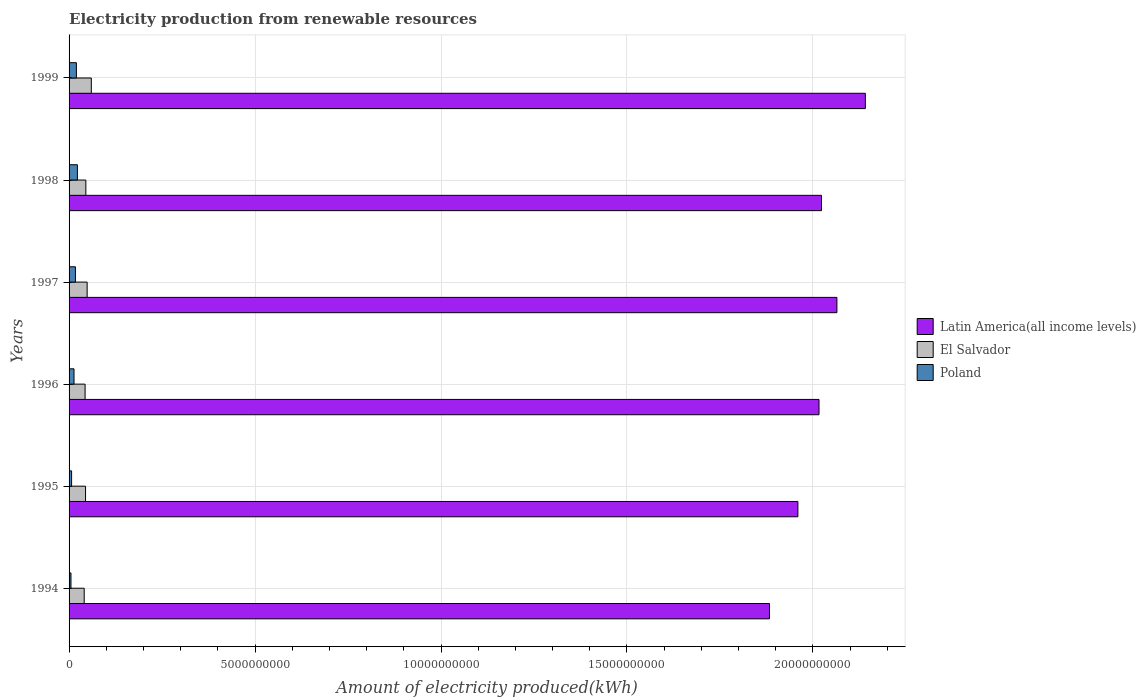Are the number of bars per tick equal to the number of legend labels?
Give a very brief answer. Yes. How many bars are there on the 1st tick from the top?
Keep it short and to the point. 3. What is the label of the 2nd group of bars from the top?
Your answer should be compact. 1998. In how many cases, is the number of bars for a given year not equal to the number of legend labels?
Provide a short and direct response. 0. What is the amount of electricity produced in Latin America(all income levels) in 1996?
Keep it short and to the point. 2.02e+1. Across all years, what is the maximum amount of electricity produced in El Salvador?
Your answer should be compact. 5.98e+08. Across all years, what is the minimum amount of electricity produced in Poland?
Give a very brief answer. 5.10e+07. In which year was the amount of electricity produced in Latin America(all income levels) maximum?
Provide a short and direct response. 1999. What is the total amount of electricity produced in Latin America(all income levels) in the graph?
Your answer should be compact. 1.21e+11. What is the difference between the amount of electricity produced in Latin America(all income levels) in 1994 and that in 1999?
Keep it short and to the point. -2.58e+09. What is the difference between the amount of electricity produced in El Salvador in 1994 and the amount of electricity produced in Latin America(all income levels) in 1996?
Your answer should be compact. -1.98e+1. What is the average amount of electricity produced in Poland per year?
Offer a terse response. 1.41e+08. In the year 1999, what is the difference between the amount of electricity produced in El Salvador and amount of electricity produced in Latin America(all income levels)?
Ensure brevity in your answer.  -2.08e+1. What is the ratio of the amount of electricity produced in Latin America(all income levels) in 1994 to that in 1996?
Give a very brief answer. 0.93. Is the amount of electricity produced in Latin America(all income levels) in 1997 less than that in 1998?
Ensure brevity in your answer.  No. Is the difference between the amount of electricity produced in El Salvador in 1995 and 1997 greater than the difference between the amount of electricity produced in Latin America(all income levels) in 1995 and 1997?
Offer a very short reply. Yes. What is the difference between the highest and the second highest amount of electricity produced in Latin America(all income levels)?
Your response must be concise. 7.65e+08. What is the difference between the highest and the lowest amount of electricity produced in Latin America(all income levels)?
Keep it short and to the point. 2.58e+09. In how many years, is the amount of electricity produced in Latin America(all income levels) greater than the average amount of electricity produced in Latin America(all income levels) taken over all years?
Your answer should be compact. 4. Is the sum of the amount of electricity produced in Latin America(all income levels) in 1996 and 1997 greater than the maximum amount of electricity produced in El Salvador across all years?
Provide a short and direct response. Yes. What does the 2nd bar from the top in 1994 represents?
Provide a short and direct response. El Salvador. What does the 3rd bar from the bottom in 1998 represents?
Make the answer very short. Poland. Is it the case that in every year, the sum of the amount of electricity produced in Latin America(all income levels) and amount of electricity produced in Poland is greater than the amount of electricity produced in El Salvador?
Provide a short and direct response. Yes. What is the difference between two consecutive major ticks on the X-axis?
Give a very brief answer. 5.00e+09. Are the values on the major ticks of X-axis written in scientific E-notation?
Your response must be concise. No. Does the graph contain any zero values?
Provide a succinct answer. No. Does the graph contain grids?
Provide a short and direct response. Yes. How many legend labels are there?
Your answer should be very brief. 3. What is the title of the graph?
Provide a succinct answer. Electricity production from renewable resources. Does "Lao PDR" appear as one of the legend labels in the graph?
Give a very brief answer. No. What is the label or title of the X-axis?
Make the answer very short. Amount of electricity produced(kWh). What is the Amount of electricity produced(kWh) of Latin America(all income levels) in 1994?
Ensure brevity in your answer.  1.88e+1. What is the Amount of electricity produced(kWh) of El Salvador in 1994?
Provide a succinct answer. 4.07e+08. What is the Amount of electricity produced(kWh) of Poland in 1994?
Your answer should be compact. 5.10e+07. What is the Amount of electricity produced(kWh) in Latin America(all income levels) in 1995?
Ensure brevity in your answer.  1.96e+1. What is the Amount of electricity produced(kWh) of El Salvador in 1995?
Give a very brief answer. 4.43e+08. What is the Amount of electricity produced(kWh) in Poland in 1995?
Your response must be concise. 6.80e+07. What is the Amount of electricity produced(kWh) in Latin America(all income levels) in 1996?
Your response must be concise. 2.02e+1. What is the Amount of electricity produced(kWh) of El Salvador in 1996?
Ensure brevity in your answer.  4.31e+08. What is the Amount of electricity produced(kWh) of Poland in 1996?
Give a very brief answer. 1.33e+08. What is the Amount of electricity produced(kWh) in Latin America(all income levels) in 1997?
Your answer should be very brief. 2.06e+1. What is the Amount of electricity produced(kWh) in El Salvador in 1997?
Ensure brevity in your answer.  4.86e+08. What is the Amount of electricity produced(kWh) of Poland in 1997?
Your answer should be compact. 1.71e+08. What is the Amount of electricity produced(kWh) of Latin America(all income levels) in 1998?
Keep it short and to the point. 2.02e+1. What is the Amount of electricity produced(kWh) in El Salvador in 1998?
Ensure brevity in your answer.  4.51e+08. What is the Amount of electricity produced(kWh) in Poland in 1998?
Provide a short and direct response. 2.24e+08. What is the Amount of electricity produced(kWh) of Latin America(all income levels) in 1999?
Offer a terse response. 2.14e+1. What is the Amount of electricity produced(kWh) in El Salvador in 1999?
Offer a terse response. 5.98e+08. What is the Amount of electricity produced(kWh) of Poland in 1999?
Your answer should be very brief. 1.97e+08. Across all years, what is the maximum Amount of electricity produced(kWh) in Latin America(all income levels)?
Give a very brief answer. 2.14e+1. Across all years, what is the maximum Amount of electricity produced(kWh) of El Salvador?
Offer a terse response. 5.98e+08. Across all years, what is the maximum Amount of electricity produced(kWh) in Poland?
Keep it short and to the point. 2.24e+08. Across all years, what is the minimum Amount of electricity produced(kWh) in Latin America(all income levels)?
Make the answer very short. 1.88e+1. Across all years, what is the minimum Amount of electricity produced(kWh) in El Salvador?
Ensure brevity in your answer.  4.07e+08. Across all years, what is the minimum Amount of electricity produced(kWh) in Poland?
Provide a succinct answer. 5.10e+07. What is the total Amount of electricity produced(kWh) of Latin America(all income levels) in the graph?
Offer a terse response. 1.21e+11. What is the total Amount of electricity produced(kWh) in El Salvador in the graph?
Your answer should be compact. 2.82e+09. What is the total Amount of electricity produced(kWh) of Poland in the graph?
Make the answer very short. 8.44e+08. What is the difference between the Amount of electricity produced(kWh) of Latin America(all income levels) in 1994 and that in 1995?
Your answer should be very brief. -7.64e+08. What is the difference between the Amount of electricity produced(kWh) of El Salvador in 1994 and that in 1995?
Keep it short and to the point. -3.60e+07. What is the difference between the Amount of electricity produced(kWh) in Poland in 1994 and that in 1995?
Offer a terse response. -1.70e+07. What is the difference between the Amount of electricity produced(kWh) of Latin America(all income levels) in 1994 and that in 1996?
Provide a short and direct response. -1.33e+09. What is the difference between the Amount of electricity produced(kWh) in El Salvador in 1994 and that in 1996?
Keep it short and to the point. -2.40e+07. What is the difference between the Amount of electricity produced(kWh) in Poland in 1994 and that in 1996?
Give a very brief answer. -8.20e+07. What is the difference between the Amount of electricity produced(kWh) of Latin America(all income levels) in 1994 and that in 1997?
Give a very brief answer. -1.81e+09. What is the difference between the Amount of electricity produced(kWh) of El Salvador in 1994 and that in 1997?
Provide a short and direct response. -7.90e+07. What is the difference between the Amount of electricity produced(kWh) in Poland in 1994 and that in 1997?
Provide a short and direct response. -1.20e+08. What is the difference between the Amount of electricity produced(kWh) of Latin America(all income levels) in 1994 and that in 1998?
Make the answer very short. -1.40e+09. What is the difference between the Amount of electricity produced(kWh) of El Salvador in 1994 and that in 1998?
Provide a short and direct response. -4.40e+07. What is the difference between the Amount of electricity produced(kWh) in Poland in 1994 and that in 1998?
Keep it short and to the point. -1.73e+08. What is the difference between the Amount of electricity produced(kWh) in Latin America(all income levels) in 1994 and that in 1999?
Your answer should be compact. -2.58e+09. What is the difference between the Amount of electricity produced(kWh) of El Salvador in 1994 and that in 1999?
Ensure brevity in your answer.  -1.91e+08. What is the difference between the Amount of electricity produced(kWh) of Poland in 1994 and that in 1999?
Your response must be concise. -1.46e+08. What is the difference between the Amount of electricity produced(kWh) of Latin America(all income levels) in 1995 and that in 1996?
Keep it short and to the point. -5.68e+08. What is the difference between the Amount of electricity produced(kWh) of Poland in 1995 and that in 1996?
Make the answer very short. -6.50e+07. What is the difference between the Amount of electricity produced(kWh) of Latin America(all income levels) in 1995 and that in 1997?
Provide a succinct answer. -1.05e+09. What is the difference between the Amount of electricity produced(kWh) of El Salvador in 1995 and that in 1997?
Offer a very short reply. -4.30e+07. What is the difference between the Amount of electricity produced(kWh) in Poland in 1995 and that in 1997?
Provide a short and direct response. -1.03e+08. What is the difference between the Amount of electricity produced(kWh) in Latin America(all income levels) in 1995 and that in 1998?
Ensure brevity in your answer.  -6.34e+08. What is the difference between the Amount of electricity produced(kWh) in El Salvador in 1995 and that in 1998?
Keep it short and to the point. -8.00e+06. What is the difference between the Amount of electricity produced(kWh) of Poland in 1995 and that in 1998?
Make the answer very short. -1.56e+08. What is the difference between the Amount of electricity produced(kWh) in Latin America(all income levels) in 1995 and that in 1999?
Provide a succinct answer. -1.81e+09. What is the difference between the Amount of electricity produced(kWh) in El Salvador in 1995 and that in 1999?
Provide a short and direct response. -1.55e+08. What is the difference between the Amount of electricity produced(kWh) in Poland in 1995 and that in 1999?
Your response must be concise. -1.29e+08. What is the difference between the Amount of electricity produced(kWh) in Latin America(all income levels) in 1996 and that in 1997?
Give a very brief answer. -4.81e+08. What is the difference between the Amount of electricity produced(kWh) of El Salvador in 1996 and that in 1997?
Your response must be concise. -5.50e+07. What is the difference between the Amount of electricity produced(kWh) of Poland in 1996 and that in 1997?
Keep it short and to the point. -3.80e+07. What is the difference between the Amount of electricity produced(kWh) in Latin America(all income levels) in 1996 and that in 1998?
Provide a succinct answer. -6.60e+07. What is the difference between the Amount of electricity produced(kWh) in El Salvador in 1996 and that in 1998?
Make the answer very short. -2.00e+07. What is the difference between the Amount of electricity produced(kWh) in Poland in 1996 and that in 1998?
Provide a succinct answer. -9.10e+07. What is the difference between the Amount of electricity produced(kWh) of Latin America(all income levels) in 1996 and that in 1999?
Your answer should be compact. -1.25e+09. What is the difference between the Amount of electricity produced(kWh) in El Salvador in 1996 and that in 1999?
Keep it short and to the point. -1.67e+08. What is the difference between the Amount of electricity produced(kWh) in Poland in 1996 and that in 1999?
Your response must be concise. -6.40e+07. What is the difference between the Amount of electricity produced(kWh) of Latin America(all income levels) in 1997 and that in 1998?
Keep it short and to the point. 4.15e+08. What is the difference between the Amount of electricity produced(kWh) of El Salvador in 1997 and that in 1998?
Your response must be concise. 3.50e+07. What is the difference between the Amount of electricity produced(kWh) of Poland in 1997 and that in 1998?
Offer a terse response. -5.30e+07. What is the difference between the Amount of electricity produced(kWh) of Latin America(all income levels) in 1997 and that in 1999?
Your answer should be compact. -7.65e+08. What is the difference between the Amount of electricity produced(kWh) in El Salvador in 1997 and that in 1999?
Keep it short and to the point. -1.12e+08. What is the difference between the Amount of electricity produced(kWh) in Poland in 1997 and that in 1999?
Provide a succinct answer. -2.60e+07. What is the difference between the Amount of electricity produced(kWh) in Latin America(all income levels) in 1998 and that in 1999?
Your response must be concise. -1.18e+09. What is the difference between the Amount of electricity produced(kWh) of El Salvador in 1998 and that in 1999?
Your response must be concise. -1.47e+08. What is the difference between the Amount of electricity produced(kWh) of Poland in 1998 and that in 1999?
Ensure brevity in your answer.  2.70e+07. What is the difference between the Amount of electricity produced(kWh) of Latin America(all income levels) in 1994 and the Amount of electricity produced(kWh) of El Salvador in 1995?
Your answer should be compact. 1.84e+1. What is the difference between the Amount of electricity produced(kWh) in Latin America(all income levels) in 1994 and the Amount of electricity produced(kWh) in Poland in 1995?
Your response must be concise. 1.88e+1. What is the difference between the Amount of electricity produced(kWh) of El Salvador in 1994 and the Amount of electricity produced(kWh) of Poland in 1995?
Your answer should be very brief. 3.39e+08. What is the difference between the Amount of electricity produced(kWh) of Latin America(all income levels) in 1994 and the Amount of electricity produced(kWh) of El Salvador in 1996?
Your response must be concise. 1.84e+1. What is the difference between the Amount of electricity produced(kWh) of Latin America(all income levels) in 1994 and the Amount of electricity produced(kWh) of Poland in 1996?
Ensure brevity in your answer.  1.87e+1. What is the difference between the Amount of electricity produced(kWh) of El Salvador in 1994 and the Amount of electricity produced(kWh) of Poland in 1996?
Ensure brevity in your answer.  2.74e+08. What is the difference between the Amount of electricity produced(kWh) in Latin America(all income levels) in 1994 and the Amount of electricity produced(kWh) in El Salvador in 1997?
Offer a very short reply. 1.83e+1. What is the difference between the Amount of electricity produced(kWh) of Latin America(all income levels) in 1994 and the Amount of electricity produced(kWh) of Poland in 1997?
Keep it short and to the point. 1.87e+1. What is the difference between the Amount of electricity produced(kWh) of El Salvador in 1994 and the Amount of electricity produced(kWh) of Poland in 1997?
Your answer should be compact. 2.36e+08. What is the difference between the Amount of electricity produced(kWh) in Latin America(all income levels) in 1994 and the Amount of electricity produced(kWh) in El Salvador in 1998?
Your answer should be compact. 1.84e+1. What is the difference between the Amount of electricity produced(kWh) of Latin America(all income levels) in 1994 and the Amount of electricity produced(kWh) of Poland in 1998?
Make the answer very short. 1.86e+1. What is the difference between the Amount of electricity produced(kWh) of El Salvador in 1994 and the Amount of electricity produced(kWh) of Poland in 1998?
Your answer should be very brief. 1.83e+08. What is the difference between the Amount of electricity produced(kWh) of Latin America(all income levels) in 1994 and the Amount of electricity produced(kWh) of El Salvador in 1999?
Give a very brief answer. 1.82e+1. What is the difference between the Amount of electricity produced(kWh) in Latin America(all income levels) in 1994 and the Amount of electricity produced(kWh) in Poland in 1999?
Make the answer very short. 1.86e+1. What is the difference between the Amount of electricity produced(kWh) in El Salvador in 1994 and the Amount of electricity produced(kWh) in Poland in 1999?
Ensure brevity in your answer.  2.10e+08. What is the difference between the Amount of electricity produced(kWh) of Latin America(all income levels) in 1995 and the Amount of electricity produced(kWh) of El Salvador in 1996?
Provide a succinct answer. 1.92e+1. What is the difference between the Amount of electricity produced(kWh) in Latin America(all income levels) in 1995 and the Amount of electricity produced(kWh) in Poland in 1996?
Your answer should be very brief. 1.95e+1. What is the difference between the Amount of electricity produced(kWh) in El Salvador in 1995 and the Amount of electricity produced(kWh) in Poland in 1996?
Ensure brevity in your answer.  3.10e+08. What is the difference between the Amount of electricity produced(kWh) in Latin America(all income levels) in 1995 and the Amount of electricity produced(kWh) in El Salvador in 1997?
Make the answer very short. 1.91e+1. What is the difference between the Amount of electricity produced(kWh) of Latin America(all income levels) in 1995 and the Amount of electricity produced(kWh) of Poland in 1997?
Your answer should be compact. 1.94e+1. What is the difference between the Amount of electricity produced(kWh) of El Salvador in 1995 and the Amount of electricity produced(kWh) of Poland in 1997?
Your answer should be very brief. 2.72e+08. What is the difference between the Amount of electricity produced(kWh) of Latin America(all income levels) in 1995 and the Amount of electricity produced(kWh) of El Salvador in 1998?
Provide a short and direct response. 1.91e+1. What is the difference between the Amount of electricity produced(kWh) in Latin America(all income levels) in 1995 and the Amount of electricity produced(kWh) in Poland in 1998?
Offer a very short reply. 1.94e+1. What is the difference between the Amount of electricity produced(kWh) of El Salvador in 1995 and the Amount of electricity produced(kWh) of Poland in 1998?
Your answer should be very brief. 2.19e+08. What is the difference between the Amount of electricity produced(kWh) of Latin America(all income levels) in 1995 and the Amount of electricity produced(kWh) of El Salvador in 1999?
Ensure brevity in your answer.  1.90e+1. What is the difference between the Amount of electricity produced(kWh) of Latin America(all income levels) in 1995 and the Amount of electricity produced(kWh) of Poland in 1999?
Ensure brevity in your answer.  1.94e+1. What is the difference between the Amount of electricity produced(kWh) in El Salvador in 1995 and the Amount of electricity produced(kWh) in Poland in 1999?
Offer a terse response. 2.46e+08. What is the difference between the Amount of electricity produced(kWh) in Latin America(all income levels) in 1996 and the Amount of electricity produced(kWh) in El Salvador in 1997?
Give a very brief answer. 1.97e+1. What is the difference between the Amount of electricity produced(kWh) of Latin America(all income levels) in 1996 and the Amount of electricity produced(kWh) of Poland in 1997?
Your answer should be compact. 2.00e+1. What is the difference between the Amount of electricity produced(kWh) in El Salvador in 1996 and the Amount of electricity produced(kWh) in Poland in 1997?
Make the answer very short. 2.60e+08. What is the difference between the Amount of electricity produced(kWh) of Latin America(all income levels) in 1996 and the Amount of electricity produced(kWh) of El Salvador in 1998?
Offer a terse response. 1.97e+1. What is the difference between the Amount of electricity produced(kWh) of Latin America(all income levels) in 1996 and the Amount of electricity produced(kWh) of Poland in 1998?
Keep it short and to the point. 1.99e+1. What is the difference between the Amount of electricity produced(kWh) of El Salvador in 1996 and the Amount of electricity produced(kWh) of Poland in 1998?
Give a very brief answer. 2.07e+08. What is the difference between the Amount of electricity produced(kWh) of Latin America(all income levels) in 1996 and the Amount of electricity produced(kWh) of El Salvador in 1999?
Keep it short and to the point. 1.96e+1. What is the difference between the Amount of electricity produced(kWh) of Latin America(all income levels) in 1996 and the Amount of electricity produced(kWh) of Poland in 1999?
Provide a succinct answer. 2.00e+1. What is the difference between the Amount of electricity produced(kWh) of El Salvador in 1996 and the Amount of electricity produced(kWh) of Poland in 1999?
Your answer should be compact. 2.34e+08. What is the difference between the Amount of electricity produced(kWh) in Latin America(all income levels) in 1997 and the Amount of electricity produced(kWh) in El Salvador in 1998?
Keep it short and to the point. 2.02e+1. What is the difference between the Amount of electricity produced(kWh) of Latin America(all income levels) in 1997 and the Amount of electricity produced(kWh) of Poland in 1998?
Your response must be concise. 2.04e+1. What is the difference between the Amount of electricity produced(kWh) of El Salvador in 1997 and the Amount of electricity produced(kWh) of Poland in 1998?
Your answer should be very brief. 2.62e+08. What is the difference between the Amount of electricity produced(kWh) of Latin America(all income levels) in 1997 and the Amount of electricity produced(kWh) of El Salvador in 1999?
Your answer should be very brief. 2.00e+1. What is the difference between the Amount of electricity produced(kWh) in Latin America(all income levels) in 1997 and the Amount of electricity produced(kWh) in Poland in 1999?
Your answer should be very brief. 2.04e+1. What is the difference between the Amount of electricity produced(kWh) in El Salvador in 1997 and the Amount of electricity produced(kWh) in Poland in 1999?
Provide a succinct answer. 2.89e+08. What is the difference between the Amount of electricity produced(kWh) in Latin America(all income levels) in 1998 and the Amount of electricity produced(kWh) in El Salvador in 1999?
Your answer should be compact. 1.96e+1. What is the difference between the Amount of electricity produced(kWh) in Latin America(all income levels) in 1998 and the Amount of electricity produced(kWh) in Poland in 1999?
Offer a very short reply. 2.00e+1. What is the difference between the Amount of electricity produced(kWh) in El Salvador in 1998 and the Amount of electricity produced(kWh) in Poland in 1999?
Keep it short and to the point. 2.54e+08. What is the average Amount of electricity produced(kWh) of Latin America(all income levels) per year?
Provide a succinct answer. 2.01e+1. What is the average Amount of electricity produced(kWh) in El Salvador per year?
Offer a very short reply. 4.69e+08. What is the average Amount of electricity produced(kWh) of Poland per year?
Provide a short and direct response. 1.41e+08. In the year 1994, what is the difference between the Amount of electricity produced(kWh) in Latin America(all income levels) and Amount of electricity produced(kWh) in El Salvador?
Your response must be concise. 1.84e+1. In the year 1994, what is the difference between the Amount of electricity produced(kWh) in Latin America(all income levels) and Amount of electricity produced(kWh) in Poland?
Ensure brevity in your answer.  1.88e+1. In the year 1994, what is the difference between the Amount of electricity produced(kWh) in El Salvador and Amount of electricity produced(kWh) in Poland?
Provide a short and direct response. 3.56e+08. In the year 1995, what is the difference between the Amount of electricity produced(kWh) of Latin America(all income levels) and Amount of electricity produced(kWh) of El Salvador?
Give a very brief answer. 1.92e+1. In the year 1995, what is the difference between the Amount of electricity produced(kWh) of Latin America(all income levels) and Amount of electricity produced(kWh) of Poland?
Make the answer very short. 1.95e+1. In the year 1995, what is the difference between the Amount of electricity produced(kWh) in El Salvador and Amount of electricity produced(kWh) in Poland?
Make the answer very short. 3.75e+08. In the year 1996, what is the difference between the Amount of electricity produced(kWh) of Latin America(all income levels) and Amount of electricity produced(kWh) of El Salvador?
Provide a succinct answer. 1.97e+1. In the year 1996, what is the difference between the Amount of electricity produced(kWh) in Latin America(all income levels) and Amount of electricity produced(kWh) in Poland?
Ensure brevity in your answer.  2.00e+1. In the year 1996, what is the difference between the Amount of electricity produced(kWh) of El Salvador and Amount of electricity produced(kWh) of Poland?
Offer a terse response. 2.98e+08. In the year 1997, what is the difference between the Amount of electricity produced(kWh) in Latin America(all income levels) and Amount of electricity produced(kWh) in El Salvador?
Your answer should be compact. 2.02e+1. In the year 1997, what is the difference between the Amount of electricity produced(kWh) in Latin America(all income levels) and Amount of electricity produced(kWh) in Poland?
Ensure brevity in your answer.  2.05e+1. In the year 1997, what is the difference between the Amount of electricity produced(kWh) of El Salvador and Amount of electricity produced(kWh) of Poland?
Your answer should be compact. 3.15e+08. In the year 1998, what is the difference between the Amount of electricity produced(kWh) of Latin America(all income levels) and Amount of electricity produced(kWh) of El Salvador?
Your answer should be very brief. 1.98e+1. In the year 1998, what is the difference between the Amount of electricity produced(kWh) of Latin America(all income levels) and Amount of electricity produced(kWh) of Poland?
Offer a very short reply. 2.00e+1. In the year 1998, what is the difference between the Amount of electricity produced(kWh) in El Salvador and Amount of electricity produced(kWh) in Poland?
Your answer should be very brief. 2.27e+08. In the year 1999, what is the difference between the Amount of electricity produced(kWh) of Latin America(all income levels) and Amount of electricity produced(kWh) of El Salvador?
Make the answer very short. 2.08e+1. In the year 1999, what is the difference between the Amount of electricity produced(kWh) of Latin America(all income levels) and Amount of electricity produced(kWh) of Poland?
Your answer should be very brief. 2.12e+1. In the year 1999, what is the difference between the Amount of electricity produced(kWh) of El Salvador and Amount of electricity produced(kWh) of Poland?
Offer a very short reply. 4.01e+08. What is the ratio of the Amount of electricity produced(kWh) of Latin America(all income levels) in 1994 to that in 1995?
Your response must be concise. 0.96. What is the ratio of the Amount of electricity produced(kWh) of El Salvador in 1994 to that in 1995?
Provide a short and direct response. 0.92. What is the ratio of the Amount of electricity produced(kWh) in Poland in 1994 to that in 1995?
Your answer should be very brief. 0.75. What is the ratio of the Amount of electricity produced(kWh) of Latin America(all income levels) in 1994 to that in 1996?
Provide a succinct answer. 0.93. What is the ratio of the Amount of electricity produced(kWh) in El Salvador in 1994 to that in 1996?
Make the answer very short. 0.94. What is the ratio of the Amount of electricity produced(kWh) of Poland in 1994 to that in 1996?
Give a very brief answer. 0.38. What is the ratio of the Amount of electricity produced(kWh) of Latin America(all income levels) in 1994 to that in 1997?
Give a very brief answer. 0.91. What is the ratio of the Amount of electricity produced(kWh) in El Salvador in 1994 to that in 1997?
Offer a terse response. 0.84. What is the ratio of the Amount of electricity produced(kWh) of Poland in 1994 to that in 1997?
Make the answer very short. 0.3. What is the ratio of the Amount of electricity produced(kWh) of Latin America(all income levels) in 1994 to that in 1998?
Make the answer very short. 0.93. What is the ratio of the Amount of electricity produced(kWh) in El Salvador in 1994 to that in 1998?
Provide a short and direct response. 0.9. What is the ratio of the Amount of electricity produced(kWh) of Poland in 1994 to that in 1998?
Your answer should be very brief. 0.23. What is the ratio of the Amount of electricity produced(kWh) in Latin America(all income levels) in 1994 to that in 1999?
Give a very brief answer. 0.88. What is the ratio of the Amount of electricity produced(kWh) of El Salvador in 1994 to that in 1999?
Make the answer very short. 0.68. What is the ratio of the Amount of electricity produced(kWh) in Poland in 1994 to that in 1999?
Your answer should be very brief. 0.26. What is the ratio of the Amount of electricity produced(kWh) of Latin America(all income levels) in 1995 to that in 1996?
Offer a very short reply. 0.97. What is the ratio of the Amount of electricity produced(kWh) in El Salvador in 1995 to that in 1996?
Your response must be concise. 1.03. What is the ratio of the Amount of electricity produced(kWh) in Poland in 1995 to that in 1996?
Keep it short and to the point. 0.51. What is the ratio of the Amount of electricity produced(kWh) of Latin America(all income levels) in 1995 to that in 1997?
Offer a very short reply. 0.95. What is the ratio of the Amount of electricity produced(kWh) in El Salvador in 1995 to that in 1997?
Provide a succinct answer. 0.91. What is the ratio of the Amount of electricity produced(kWh) of Poland in 1995 to that in 1997?
Give a very brief answer. 0.4. What is the ratio of the Amount of electricity produced(kWh) in Latin America(all income levels) in 1995 to that in 1998?
Provide a short and direct response. 0.97. What is the ratio of the Amount of electricity produced(kWh) in El Salvador in 1995 to that in 1998?
Give a very brief answer. 0.98. What is the ratio of the Amount of electricity produced(kWh) in Poland in 1995 to that in 1998?
Ensure brevity in your answer.  0.3. What is the ratio of the Amount of electricity produced(kWh) in Latin America(all income levels) in 1995 to that in 1999?
Offer a terse response. 0.92. What is the ratio of the Amount of electricity produced(kWh) in El Salvador in 1995 to that in 1999?
Provide a short and direct response. 0.74. What is the ratio of the Amount of electricity produced(kWh) in Poland in 1995 to that in 1999?
Offer a very short reply. 0.35. What is the ratio of the Amount of electricity produced(kWh) in Latin America(all income levels) in 1996 to that in 1997?
Keep it short and to the point. 0.98. What is the ratio of the Amount of electricity produced(kWh) of El Salvador in 1996 to that in 1997?
Your answer should be compact. 0.89. What is the ratio of the Amount of electricity produced(kWh) in Poland in 1996 to that in 1997?
Your answer should be very brief. 0.78. What is the ratio of the Amount of electricity produced(kWh) in El Salvador in 1996 to that in 1998?
Your answer should be very brief. 0.96. What is the ratio of the Amount of electricity produced(kWh) of Poland in 1996 to that in 1998?
Offer a terse response. 0.59. What is the ratio of the Amount of electricity produced(kWh) of Latin America(all income levels) in 1996 to that in 1999?
Offer a terse response. 0.94. What is the ratio of the Amount of electricity produced(kWh) of El Salvador in 1996 to that in 1999?
Offer a very short reply. 0.72. What is the ratio of the Amount of electricity produced(kWh) of Poland in 1996 to that in 1999?
Provide a succinct answer. 0.68. What is the ratio of the Amount of electricity produced(kWh) of Latin America(all income levels) in 1997 to that in 1998?
Ensure brevity in your answer.  1.02. What is the ratio of the Amount of electricity produced(kWh) in El Salvador in 1997 to that in 1998?
Ensure brevity in your answer.  1.08. What is the ratio of the Amount of electricity produced(kWh) in Poland in 1997 to that in 1998?
Your response must be concise. 0.76. What is the ratio of the Amount of electricity produced(kWh) of Latin America(all income levels) in 1997 to that in 1999?
Keep it short and to the point. 0.96. What is the ratio of the Amount of electricity produced(kWh) in El Salvador in 1997 to that in 1999?
Make the answer very short. 0.81. What is the ratio of the Amount of electricity produced(kWh) of Poland in 1997 to that in 1999?
Make the answer very short. 0.87. What is the ratio of the Amount of electricity produced(kWh) in Latin America(all income levels) in 1998 to that in 1999?
Provide a short and direct response. 0.94. What is the ratio of the Amount of electricity produced(kWh) in El Salvador in 1998 to that in 1999?
Provide a short and direct response. 0.75. What is the ratio of the Amount of electricity produced(kWh) in Poland in 1998 to that in 1999?
Your answer should be very brief. 1.14. What is the difference between the highest and the second highest Amount of electricity produced(kWh) in Latin America(all income levels)?
Your answer should be compact. 7.65e+08. What is the difference between the highest and the second highest Amount of electricity produced(kWh) of El Salvador?
Ensure brevity in your answer.  1.12e+08. What is the difference between the highest and the second highest Amount of electricity produced(kWh) in Poland?
Your answer should be compact. 2.70e+07. What is the difference between the highest and the lowest Amount of electricity produced(kWh) of Latin America(all income levels)?
Make the answer very short. 2.58e+09. What is the difference between the highest and the lowest Amount of electricity produced(kWh) of El Salvador?
Keep it short and to the point. 1.91e+08. What is the difference between the highest and the lowest Amount of electricity produced(kWh) of Poland?
Your answer should be very brief. 1.73e+08. 